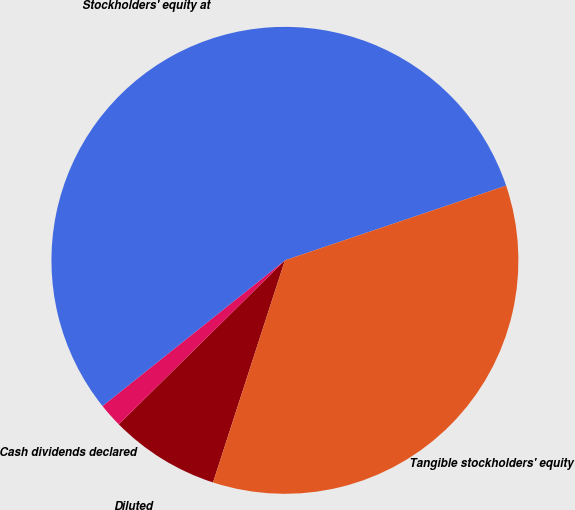Convert chart to OTSL. <chart><loc_0><loc_0><loc_500><loc_500><pie_chart><fcel>Diluted<fcel>Cash dividends declared<fcel>Stockholders' equity at<fcel>Tangible stockholders' equity<nl><fcel>7.62%<fcel>1.67%<fcel>55.54%<fcel>35.16%<nl></chart> 